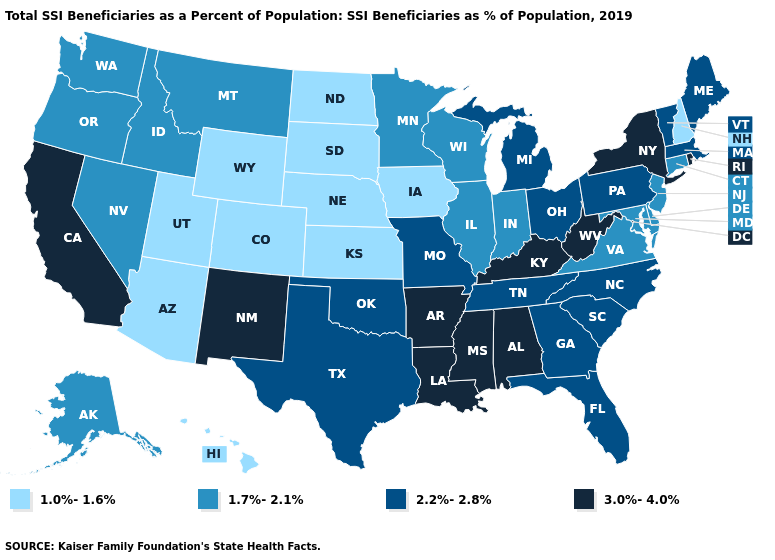Does Texas have a lower value than Michigan?
Short answer required. No. Does Washington have the same value as Iowa?
Be succinct. No. Name the states that have a value in the range 3.0%-4.0%?
Short answer required. Alabama, Arkansas, California, Kentucky, Louisiana, Mississippi, New Mexico, New York, Rhode Island, West Virginia. What is the value of Hawaii?
Quick response, please. 1.0%-1.6%. What is the value of New Mexico?
Keep it brief. 3.0%-4.0%. What is the lowest value in the USA?
Concise answer only. 1.0%-1.6%. Among the states that border New York , which have the lowest value?
Keep it brief. Connecticut, New Jersey. What is the value of South Dakota?
Short answer required. 1.0%-1.6%. What is the value of Iowa?
Be succinct. 1.0%-1.6%. Name the states that have a value in the range 1.7%-2.1%?
Answer briefly. Alaska, Connecticut, Delaware, Idaho, Illinois, Indiana, Maryland, Minnesota, Montana, Nevada, New Jersey, Oregon, Virginia, Washington, Wisconsin. What is the value of South Dakota?
Concise answer only. 1.0%-1.6%. What is the lowest value in the USA?
Give a very brief answer. 1.0%-1.6%. Which states have the highest value in the USA?
Short answer required. Alabama, Arkansas, California, Kentucky, Louisiana, Mississippi, New Mexico, New York, Rhode Island, West Virginia. Name the states that have a value in the range 1.7%-2.1%?
Be succinct. Alaska, Connecticut, Delaware, Idaho, Illinois, Indiana, Maryland, Minnesota, Montana, Nevada, New Jersey, Oregon, Virginia, Washington, Wisconsin. 